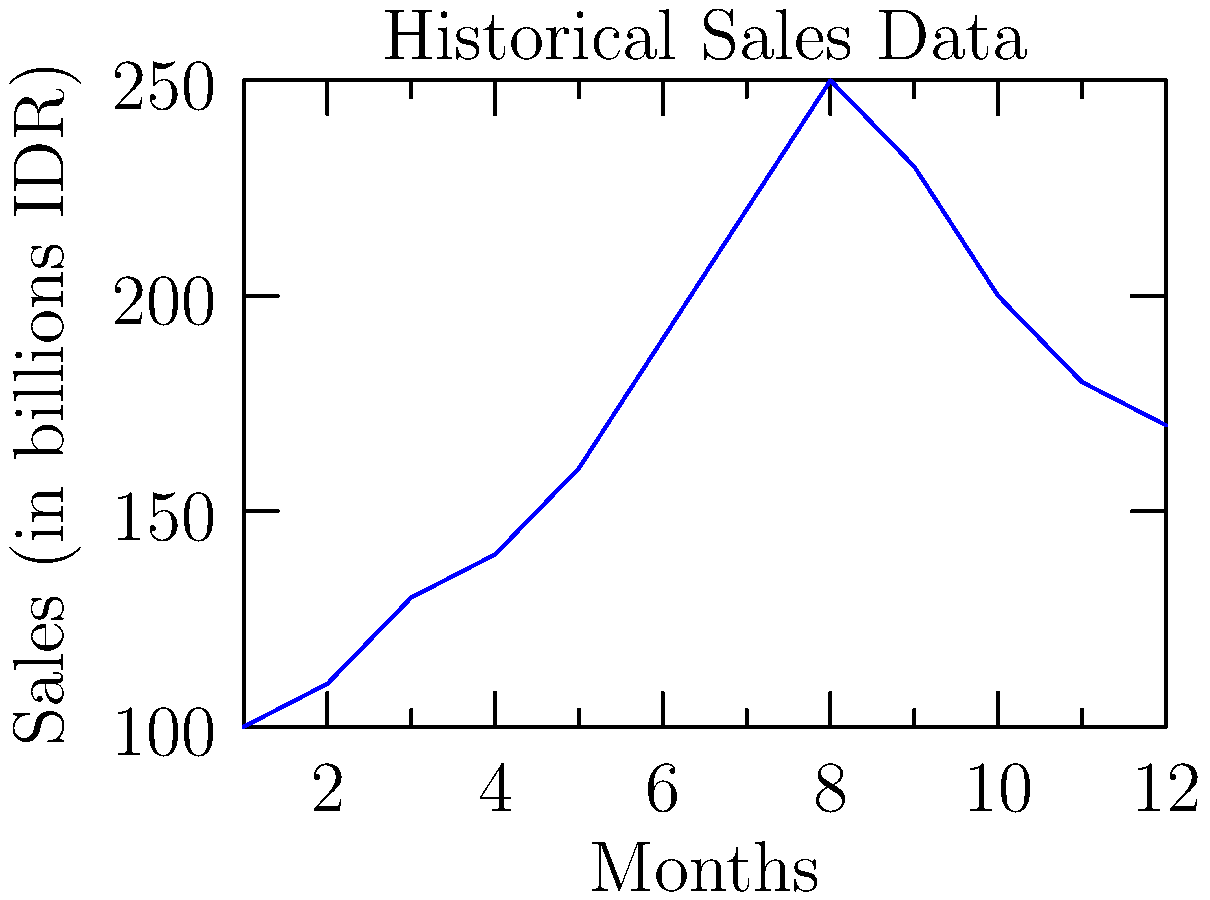As a business analyst for an Indonesian consumer goods company, you're analyzing the sales trend shown in the graph. Which time series forecasting method would be most appropriate to predict future sales, considering the clear seasonal pattern and overall upward trend? To determine the most appropriate time series forecasting method, let's analyze the graph step-by-step:

1. Observe the overall trend: There's a general upward trend from month 1 to 12.

2. Identify seasonality: The sales peak around month 8 and decline towards the end of the year, suggesting a seasonal pattern.

3. Consider the components:
   - Trend: Upward
   - Seasonality: Present
   - Cyclical component: Not clearly visible in this short time frame

4. Evaluate forecasting methods:
   - Simple moving average: Not suitable due to trend and seasonality
   - Exponential smoothing: Better, but doesn't capture seasonality well
   - ARIMA: Can handle trend but requires manual seasonal adjustment
   - Seasonal ARIMA (SARIMA): Can capture both trend and seasonality
   - Holt-Winters' method: Specifically designed for data with trend and seasonality

5. Choose the method: Given the clear seasonal pattern and overall trend, the Holt-Winters' method (also known as triple exponential smoothing) would be most appropriate. It can capture:
   - Level
   - Trend
   - Seasonality

This method is particularly suitable for retail sales in consumer goods, where seasonal patterns are common due to factors like holidays, weather, and promotional cycles.
Answer: Holt-Winters' method 